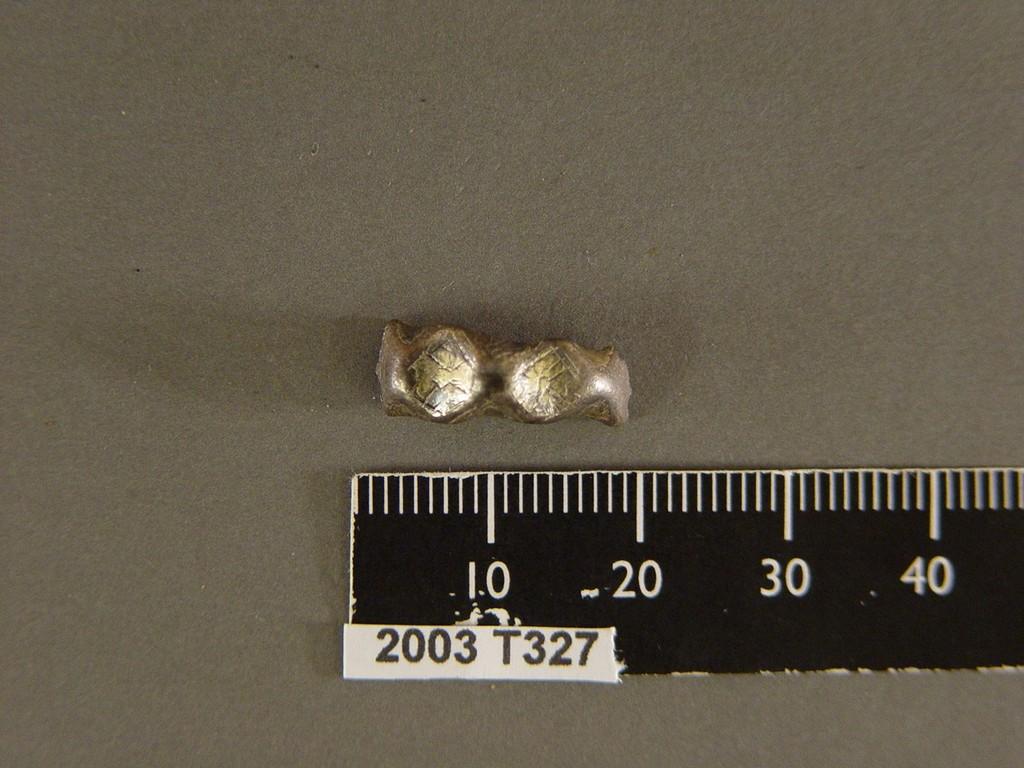What date is on this ruler?
Provide a succinct answer. 2003. 